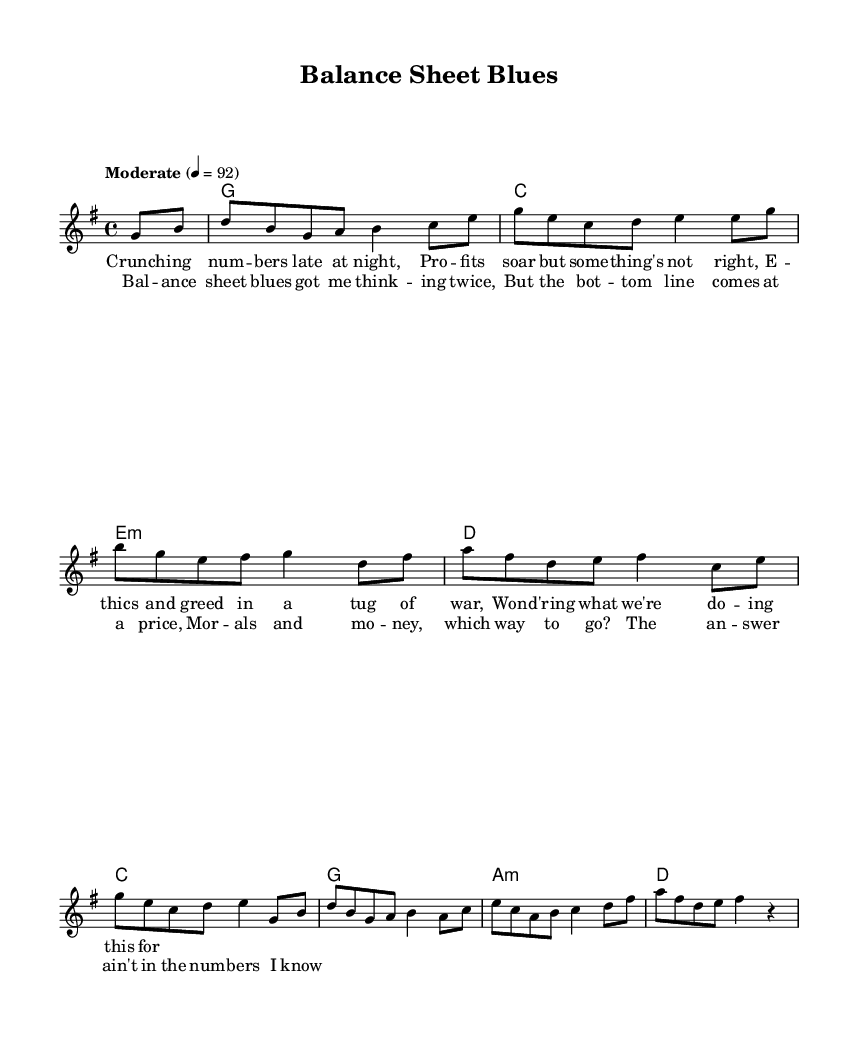What is the key signature of this music? The key signature is G major, which has one sharp (F#). This is indicated at the beginning of the staff.
Answer: G major What is the time signature of this music? The time signature is 4/4, which is displayed at the beginning of the score. This indicates that there are four beats per measure and the quarter note gets one beat.
Answer: 4/4 What is the tempo marking of the piece? The tempo marking is "Moderate" with a metronome marking of 92 beats per minute. This indicates the overall speed at which the piece should be played.
Answer: Moderate How many measures are in the melody? The melody consists of 10 measures, which can be counted by identifying the measures bordered by vertical lines in the score.
Answer: 10 What is the first word of the chorus lyrics? The first word of the chorus lyrics is "Balance." This can be found by inspecting the lyric section corresponding to the melody's chorus.
Answer: Balance Which chord appears at the end of the first measure? The chord at the end of the first measure is a rest, indicated by the "s" symbol that signifies silence in the score, followed by the G major chord in the next measure.
Answer: rest What ethical theme is highlighted in the song? The ethical theme highlighted is the conflict between morals and money, as expressed in the lyrics that discuss the tension between profit and ethical considerations in business.
Answer: morals and money 